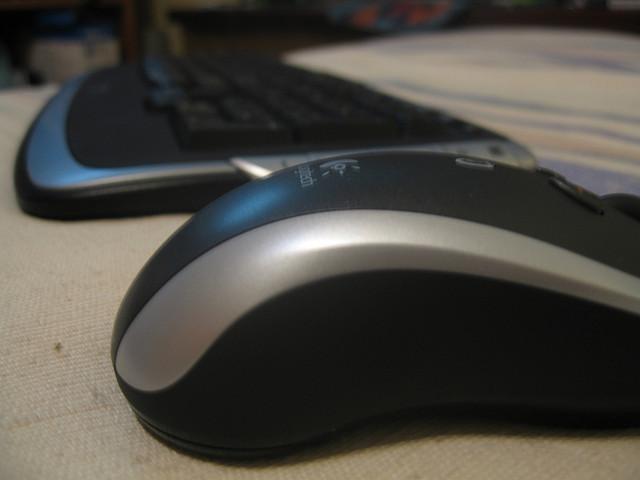How many bunches of bananas are shown?
Give a very brief answer. 0. 